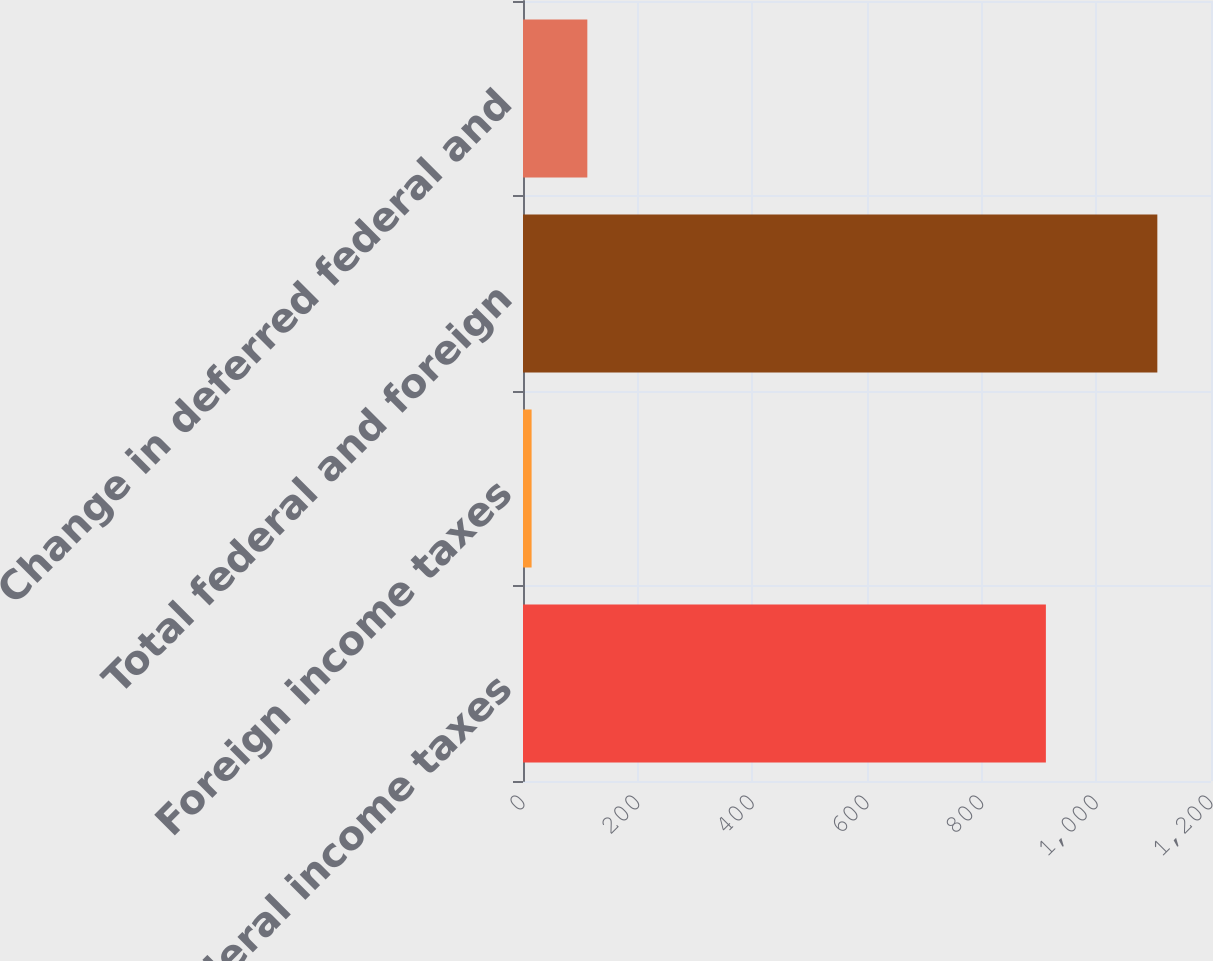Convert chart to OTSL. <chart><loc_0><loc_0><loc_500><loc_500><bar_chart><fcel>Federal income taxes<fcel>Foreign income taxes<fcel>Total federal and foreign<fcel>Change in deferred federal and<nl><fcel>912<fcel>15<fcel>1106.4<fcel>112.2<nl></chart> 